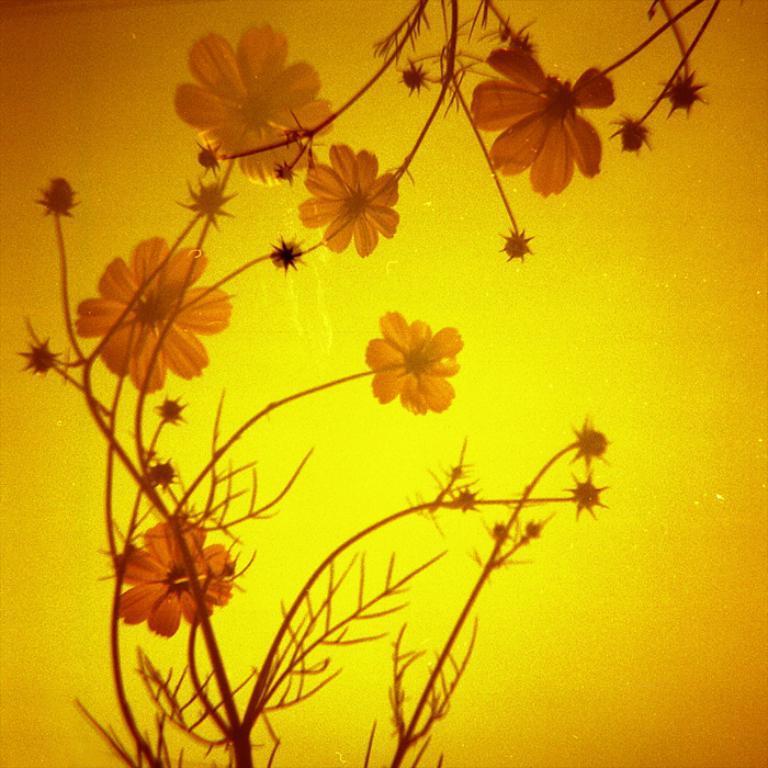Could you give a brief overview of what you see in this image? In this picture I can see flowers to the plants. 